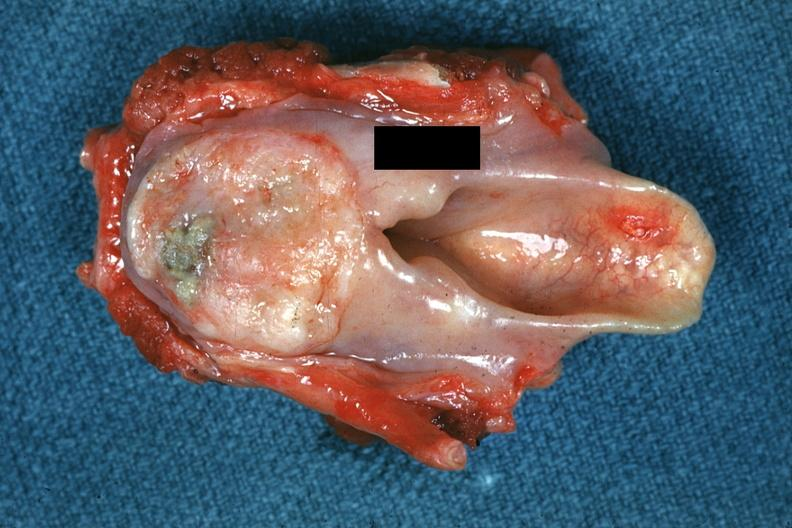s hand present?
Answer the question using a single word or phrase. No 